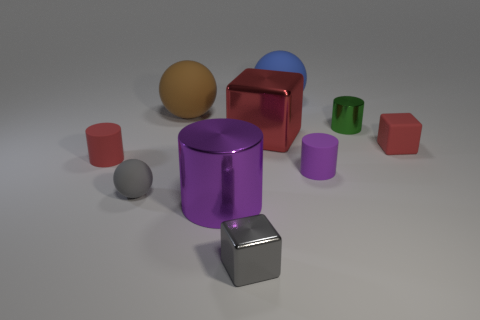Subtract all tiny balls. How many balls are left? 2 Add 5 brown things. How many brown things exist? 6 Subtract all gray cubes. How many cubes are left? 2 Subtract 1 gray balls. How many objects are left? 9 Subtract all spheres. How many objects are left? 7 Subtract 1 blocks. How many blocks are left? 2 Subtract all purple spheres. Subtract all green cylinders. How many spheres are left? 3 Subtract all cyan blocks. How many red cylinders are left? 1 Subtract all big red shiny things. Subtract all red rubber things. How many objects are left? 7 Add 7 purple things. How many purple things are left? 9 